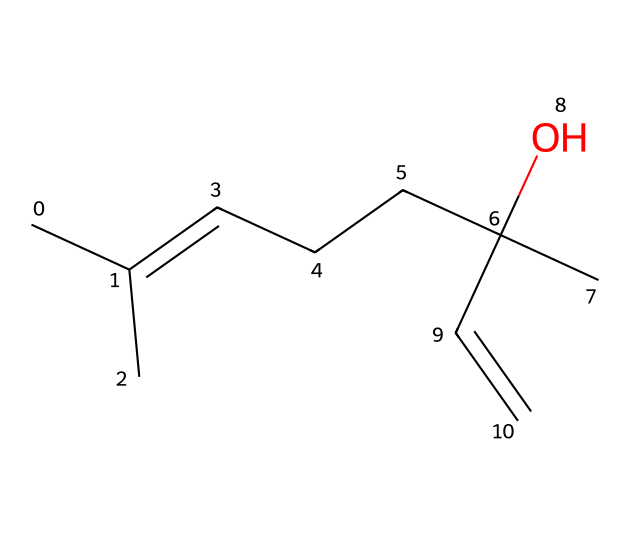What is the molecular formula of linalool? To determine the molecular formula, we can count the number of carbon (C), hydrogen (H), and oxygen (O) atoms in the chemical structure. The visible structure indicates there are 10 carbon atoms, 18 hydrogen atoms, and 1 oxygen atom, leading us to the formula C10H18O.
Answer: C10H18O How many double bonds are present in the linalool structure? By examining the SMILES representation, we look for the "=" symbol, which indicates a double bond. There is one "=" in the structure, meaning linalool contains one double bond.
Answer: 1 Is linalool a saturated or unsaturated compound? Since the presence of a double bond (as indicated by the "=" symbol) reduces the number of hydrogen atoms possible, linalool is classified as an unsaturated compound.
Answer: unsaturated What functional group is present in linalool? In the structure, we see the hydroxyl group (-OH) connected to a carbon atom, which characterizes linalool as an alcohol, indicating that the functional group is a hydroxyl group.
Answer: hydroxyl What type of compound is linalool categorized as? Linalool's structure contains two functional classifications: it is a terpene due to its natural plant-derived origin and an alcohol due to the presence of the hydroxyl group. Therefore, it is commonly categorized as a terpene alcohol.
Answer: terpene alcohol What is the total number of rings in the linalool structure? By analyzing the structure, there are no rings as indicated by the absence of closed loops within the SMILES notation or in the visual structure.
Answer: 0 How many chirality centers does linalool have? Chirality centers are typically carbons that are attached to four different substituents. In this structure, there are two such carbon atoms fulfilling this criterion, indicating there are two chirality centers in linalool.
Answer: 2 